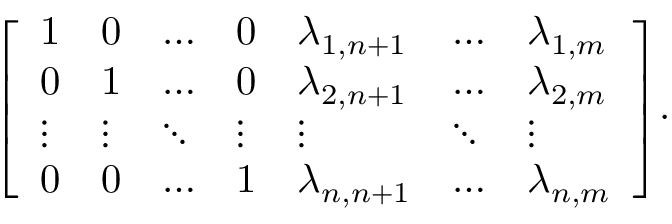Convert formula to latex. <formula><loc_0><loc_0><loc_500><loc_500>{ \left [ \begin{array} { l l l l l l l } { 1 } & { 0 } & { \dots } & { 0 } & { \lambda _ { 1 , n + 1 } } & { \dots } & { \lambda _ { 1 , m } } \\ { 0 } & { 1 } & { \dots } & { 0 } & { \lambda _ { 2 , n + 1 } } & { \dots } & { \lambda _ { 2 , m } } \\ { \vdots } & { \vdots } & { \ddots } & { \vdots } & { \vdots } & { \ddots } & { \vdots } \\ { 0 } & { 0 } & { \dots } & { 1 } & { \lambda _ { n , n + 1 } } & { \dots } & { \lambda _ { n , m } } \end{array} \right ] } .</formula> 